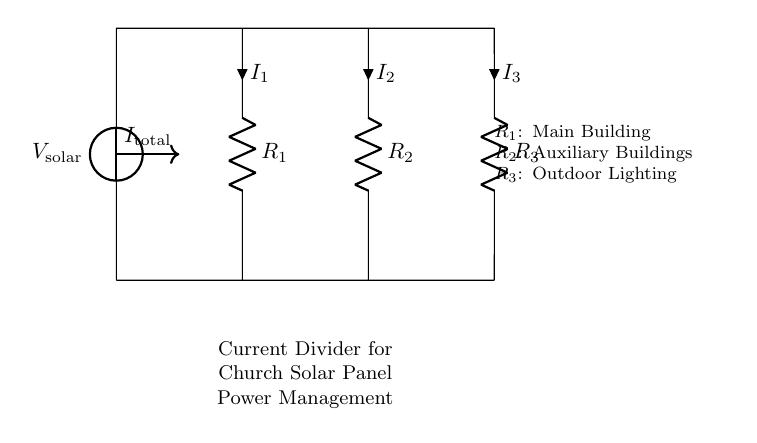What is the total current entering the circuit? The total current entering the circuit is represented as I_total, shown with an arrow pointing into the junction where all three resistors connect.
Answer: I_total What are the resistances in the circuit? The resistances in the circuit are R_1, R_2, and R_3, which are labeled next to each respective resistor in the circuit diagram.
Answer: R_1, R_2, R_3 Which component has the highest current? In a current divider circuit, the component with the lowest resistance typically receives the highest current. In this circuit, we would compare the values of R_1, R_2, and R_3 to determine which has the lowest resistance.
Answer: R_1 (if it is the lowest) What is the main function of this circuit? The main function of a current divider is to split the total current into smaller currents that flow through individual branches according to their resistances, which is essential for managing power distribution in a solar panel installation.
Answer: Current division How would you calculate the current through R_2? The current through R_2 can be calculated using the current divider rule, which states that the current through a resistor in parallel is inversely proportional to its resistance relative to the total resistance. The formula is I_2 = I_total * (R_total / R_2), where R_total is the equivalent resistance of the resistors in parallel.
Answer: I_2 = I_total * (R_total / R_2) 